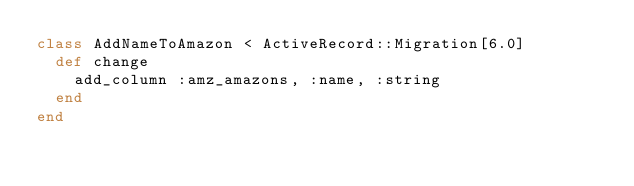Convert code to text. <code><loc_0><loc_0><loc_500><loc_500><_Ruby_>class AddNameToAmazon < ActiveRecord::Migration[6.0]
  def change
    add_column :amz_amazons, :name, :string   
  end
end
</code> 